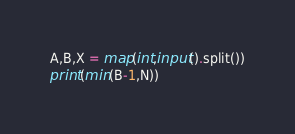Convert code to text. <code><loc_0><loc_0><loc_500><loc_500><_Python_>A,B,X = map(int,input().split())
print(min(B-1,N))</code> 